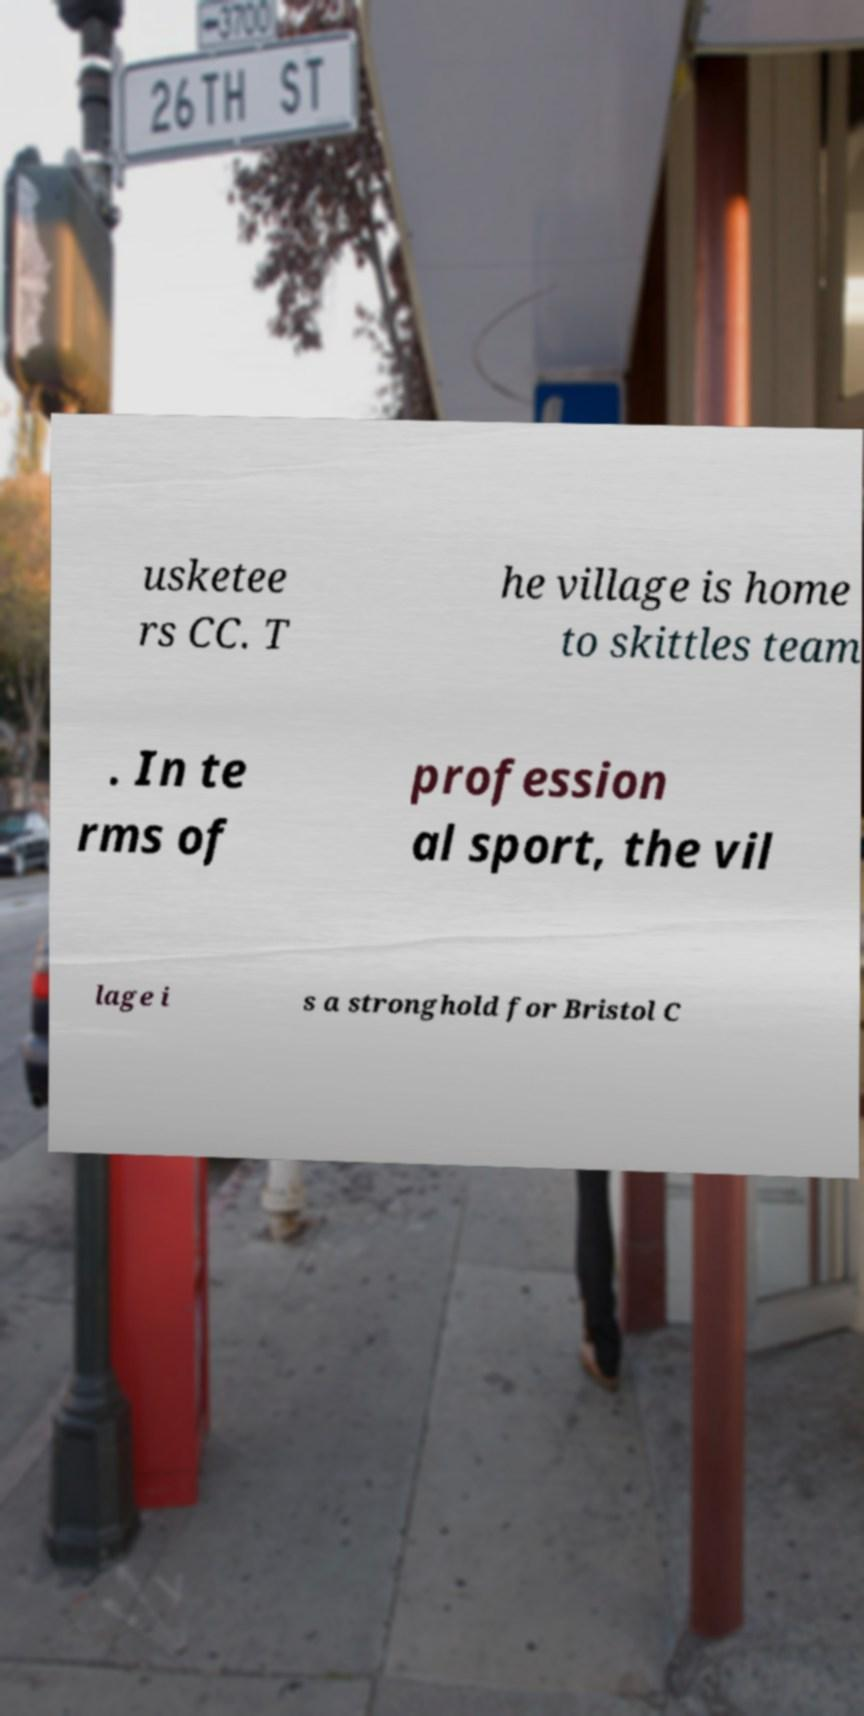There's text embedded in this image that I need extracted. Can you transcribe it verbatim? usketee rs CC. T he village is home to skittles team . In te rms of profession al sport, the vil lage i s a stronghold for Bristol C 